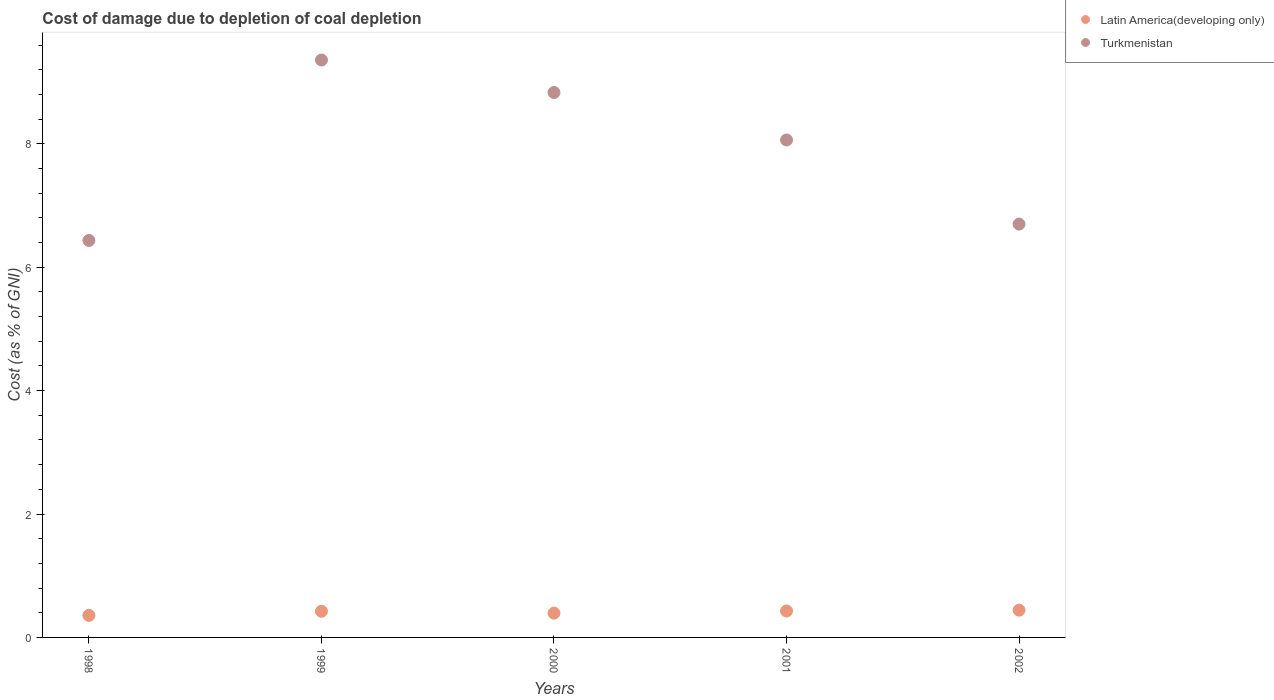How many different coloured dotlines are there?
Your answer should be very brief. 2. Is the number of dotlines equal to the number of legend labels?
Ensure brevity in your answer.  Yes. What is the cost of damage caused due to coal depletion in Turkmenistan in 1998?
Keep it short and to the point. 6.43. Across all years, what is the maximum cost of damage caused due to coal depletion in Latin America(developing only)?
Your answer should be very brief. 0.44. Across all years, what is the minimum cost of damage caused due to coal depletion in Latin America(developing only)?
Keep it short and to the point. 0.36. What is the total cost of damage caused due to coal depletion in Latin America(developing only) in the graph?
Make the answer very short. 2.05. What is the difference between the cost of damage caused due to coal depletion in Latin America(developing only) in 1998 and that in 2000?
Keep it short and to the point. -0.04. What is the difference between the cost of damage caused due to coal depletion in Latin America(developing only) in 2000 and the cost of damage caused due to coal depletion in Turkmenistan in 2001?
Your response must be concise. -7.67. What is the average cost of damage caused due to coal depletion in Latin America(developing only) per year?
Provide a short and direct response. 0.41. In the year 2000, what is the difference between the cost of damage caused due to coal depletion in Latin America(developing only) and cost of damage caused due to coal depletion in Turkmenistan?
Ensure brevity in your answer.  -8.44. What is the ratio of the cost of damage caused due to coal depletion in Latin America(developing only) in 1999 to that in 2001?
Offer a terse response. 0.99. Is the cost of damage caused due to coal depletion in Latin America(developing only) in 1998 less than that in 2002?
Your response must be concise. Yes. What is the difference between the highest and the second highest cost of damage caused due to coal depletion in Latin America(developing only)?
Offer a very short reply. 0.01. What is the difference between the highest and the lowest cost of damage caused due to coal depletion in Turkmenistan?
Provide a succinct answer. 2.92. Is the sum of the cost of damage caused due to coal depletion in Latin America(developing only) in 1998 and 2001 greater than the maximum cost of damage caused due to coal depletion in Turkmenistan across all years?
Provide a succinct answer. No. Is the cost of damage caused due to coal depletion in Latin America(developing only) strictly less than the cost of damage caused due to coal depletion in Turkmenistan over the years?
Your response must be concise. Yes. Are the values on the major ticks of Y-axis written in scientific E-notation?
Give a very brief answer. No. How many legend labels are there?
Your answer should be compact. 2. What is the title of the graph?
Offer a very short reply. Cost of damage due to depletion of coal depletion. What is the label or title of the Y-axis?
Offer a terse response. Cost (as % of GNI). What is the Cost (as % of GNI) of Latin America(developing only) in 1998?
Offer a very short reply. 0.36. What is the Cost (as % of GNI) in Turkmenistan in 1998?
Keep it short and to the point. 6.43. What is the Cost (as % of GNI) of Latin America(developing only) in 1999?
Provide a succinct answer. 0.42. What is the Cost (as % of GNI) of Turkmenistan in 1999?
Provide a short and direct response. 9.36. What is the Cost (as % of GNI) of Latin America(developing only) in 2000?
Give a very brief answer. 0.39. What is the Cost (as % of GNI) in Turkmenistan in 2000?
Give a very brief answer. 8.83. What is the Cost (as % of GNI) of Latin America(developing only) in 2001?
Your response must be concise. 0.43. What is the Cost (as % of GNI) of Turkmenistan in 2001?
Your response must be concise. 8.06. What is the Cost (as % of GNI) of Latin America(developing only) in 2002?
Offer a very short reply. 0.44. What is the Cost (as % of GNI) in Turkmenistan in 2002?
Make the answer very short. 6.7. Across all years, what is the maximum Cost (as % of GNI) of Latin America(developing only)?
Keep it short and to the point. 0.44. Across all years, what is the maximum Cost (as % of GNI) of Turkmenistan?
Provide a succinct answer. 9.36. Across all years, what is the minimum Cost (as % of GNI) of Latin America(developing only)?
Provide a succinct answer. 0.36. Across all years, what is the minimum Cost (as % of GNI) of Turkmenistan?
Provide a short and direct response. 6.43. What is the total Cost (as % of GNI) of Latin America(developing only) in the graph?
Keep it short and to the point. 2.05. What is the total Cost (as % of GNI) of Turkmenistan in the graph?
Your response must be concise. 39.38. What is the difference between the Cost (as % of GNI) of Latin America(developing only) in 1998 and that in 1999?
Your answer should be compact. -0.07. What is the difference between the Cost (as % of GNI) of Turkmenistan in 1998 and that in 1999?
Provide a succinct answer. -2.92. What is the difference between the Cost (as % of GNI) of Latin America(developing only) in 1998 and that in 2000?
Offer a very short reply. -0.04. What is the difference between the Cost (as % of GNI) in Turkmenistan in 1998 and that in 2000?
Your answer should be very brief. -2.4. What is the difference between the Cost (as % of GNI) in Latin America(developing only) in 1998 and that in 2001?
Provide a short and direct response. -0.07. What is the difference between the Cost (as % of GNI) of Turkmenistan in 1998 and that in 2001?
Keep it short and to the point. -1.63. What is the difference between the Cost (as % of GNI) in Latin America(developing only) in 1998 and that in 2002?
Ensure brevity in your answer.  -0.08. What is the difference between the Cost (as % of GNI) of Turkmenistan in 1998 and that in 2002?
Your answer should be compact. -0.27. What is the difference between the Cost (as % of GNI) of Latin America(developing only) in 1999 and that in 2000?
Make the answer very short. 0.03. What is the difference between the Cost (as % of GNI) of Turkmenistan in 1999 and that in 2000?
Provide a short and direct response. 0.53. What is the difference between the Cost (as % of GNI) of Latin America(developing only) in 1999 and that in 2001?
Provide a short and direct response. -0.01. What is the difference between the Cost (as % of GNI) in Turkmenistan in 1999 and that in 2001?
Provide a succinct answer. 1.3. What is the difference between the Cost (as % of GNI) of Latin America(developing only) in 1999 and that in 2002?
Offer a terse response. -0.02. What is the difference between the Cost (as % of GNI) of Turkmenistan in 1999 and that in 2002?
Give a very brief answer. 2.66. What is the difference between the Cost (as % of GNI) of Latin America(developing only) in 2000 and that in 2001?
Offer a terse response. -0.04. What is the difference between the Cost (as % of GNI) of Turkmenistan in 2000 and that in 2001?
Ensure brevity in your answer.  0.77. What is the difference between the Cost (as % of GNI) in Latin America(developing only) in 2000 and that in 2002?
Your response must be concise. -0.05. What is the difference between the Cost (as % of GNI) of Turkmenistan in 2000 and that in 2002?
Your answer should be very brief. 2.13. What is the difference between the Cost (as % of GNI) of Latin America(developing only) in 2001 and that in 2002?
Your answer should be compact. -0.01. What is the difference between the Cost (as % of GNI) of Turkmenistan in 2001 and that in 2002?
Give a very brief answer. 1.36. What is the difference between the Cost (as % of GNI) in Latin America(developing only) in 1998 and the Cost (as % of GNI) in Turkmenistan in 1999?
Give a very brief answer. -9. What is the difference between the Cost (as % of GNI) in Latin America(developing only) in 1998 and the Cost (as % of GNI) in Turkmenistan in 2000?
Offer a very short reply. -8.47. What is the difference between the Cost (as % of GNI) of Latin America(developing only) in 1998 and the Cost (as % of GNI) of Turkmenistan in 2001?
Give a very brief answer. -7.7. What is the difference between the Cost (as % of GNI) of Latin America(developing only) in 1998 and the Cost (as % of GNI) of Turkmenistan in 2002?
Ensure brevity in your answer.  -6.34. What is the difference between the Cost (as % of GNI) of Latin America(developing only) in 1999 and the Cost (as % of GNI) of Turkmenistan in 2000?
Offer a terse response. -8.41. What is the difference between the Cost (as % of GNI) of Latin America(developing only) in 1999 and the Cost (as % of GNI) of Turkmenistan in 2001?
Ensure brevity in your answer.  -7.64. What is the difference between the Cost (as % of GNI) of Latin America(developing only) in 1999 and the Cost (as % of GNI) of Turkmenistan in 2002?
Make the answer very short. -6.27. What is the difference between the Cost (as % of GNI) in Latin America(developing only) in 2000 and the Cost (as % of GNI) in Turkmenistan in 2001?
Provide a short and direct response. -7.67. What is the difference between the Cost (as % of GNI) of Latin America(developing only) in 2000 and the Cost (as % of GNI) of Turkmenistan in 2002?
Your answer should be compact. -6.3. What is the difference between the Cost (as % of GNI) in Latin America(developing only) in 2001 and the Cost (as % of GNI) in Turkmenistan in 2002?
Give a very brief answer. -6.27. What is the average Cost (as % of GNI) of Latin America(developing only) per year?
Your answer should be compact. 0.41. What is the average Cost (as % of GNI) in Turkmenistan per year?
Keep it short and to the point. 7.88. In the year 1998, what is the difference between the Cost (as % of GNI) of Latin America(developing only) and Cost (as % of GNI) of Turkmenistan?
Ensure brevity in your answer.  -6.08. In the year 1999, what is the difference between the Cost (as % of GNI) of Latin America(developing only) and Cost (as % of GNI) of Turkmenistan?
Provide a succinct answer. -8.93. In the year 2000, what is the difference between the Cost (as % of GNI) of Latin America(developing only) and Cost (as % of GNI) of Turkmenistan?
Give a very brief answer. -8.44. In the year 2001, what is the difference between the Cost (as % of GNI) of Latin America(developing only) and Cost (as % of GNI) of Turkmenistan?
Offer a very short reply. -7.63. In the year 2002, what is the difference between the Cost (as % of GNI) of Latin America(developing only) and Cost (as % of GNI) of Turkmenistan?
Provide a short and direct response. -6.26. What is the ratio of the Cost (as % of GNI) in Latin America(developing only) in 1998 to that in 1999?
Offer a very short reply. 0.84. What is the ratio of the Cost (as % of GNI) of Turkmenistan in 1998 to that in 1999?
Offer a very short reply. 0.69. What is the ratio of the Cost (as % of GNI) of Latin America(developing only) in 1998 to that in 2000?
Your answer should be very brief. 0.91. What is the ratio of the Cost (as % of GNI) of Turkmenistan in 1998 to that in 2000?
Your answer should be compact. 0.73. What is the ratio of the Cost (as % of GNI) in Latin America(developing only) in 1998 to that in 2001?
Give a very brief answer. 0.83. What is the ratio of the Cost (as % of GNI) of Turkmenistan in 1998 to that in 2001?
Provide a short and direct response. 0.8. What is the ratio of the Cost (as % of GNI) of Latin America(developing only) in 1998 to that in 2002?
Make the answer very short. 0.81. What is the ratio of the Cost (as % of GNI) of Turkmenistan in 1998 to that in 2002?
Your response must be concise. 0.96. What is the ratio of the Cost (as % of GNI) of Latin America(developing only) in 1999 to that in 2000?
Ensure brevity in your answer.  1.08. What is the ratio of the Cost (as % of GNI) of Turkmenistan in 1999 to that in 2000?
Offer a terse response. 1.06. What is the ratio of the Cost (as % of GNI) in Latin America(developing only) in 1999 to that in 2001?
Give a very brief answer. 0.99. What is the ratio of the Cost (as % of GNI) in Turkmenistan in 1999 to that in 2001?
Offer a very short reply. 1.16. What is the ratio of the Cost (as % of GNI) of Latin America(developing only) in 1999 to that in 2002?
Offer a very short reply. 0.96. What is the ratio of the Cost (as % of GNI) of Turkmenistan in 1999 to that in 2002?
Offer a very short reply. 1.4. What is the ratio of the Cost (as % of GNI) of Latin America(developing only) in 2000 to that in 2001?
Your response must be concise. 0.92. What is the ratio of the Cost (as % of GNI) in Turkmenistan in 2000 to that in 2001?
Your response must be concise. 1.1. What is the ratio of the Cost (as % of GNI) of Latin America(developing only) in 2000 to that in 2002?
Make the answer very short. 0.89. What is the ratio of the Cost (as % of GNI) of Turkmenistan in 2000 to that in 2002?
Keep it short and to the point. 1.32. What is the ratio of the Cost (as % of GNI) of Latin America(developing only) in 2001 to that in 2002?
Your response must be concise. 0.97. What is the ratio of the Cost (as % of GNI) of Turkmenistan in 2001 to that in 2002?
Your response must be concise. 1.2. What is the difference between the highest and the second highest Cost (as % of GNI) of Latin America(developing only)?
Offer a very short reply. 0.01. What is the difference between the highest and the second highest Cost (as % of GNI) of Turkmenistan?
Provide a succinct answer. 0.53. What is the difference between the highest and the lowest Cost (as % of GNI) of Latin America(developing only)?
Keep it short and to the point. 0.08. What is the difference between the highest and the lowest Cost (as % of GNI) of Turkmenistan?
Your answer should be very brief. 2.92. 